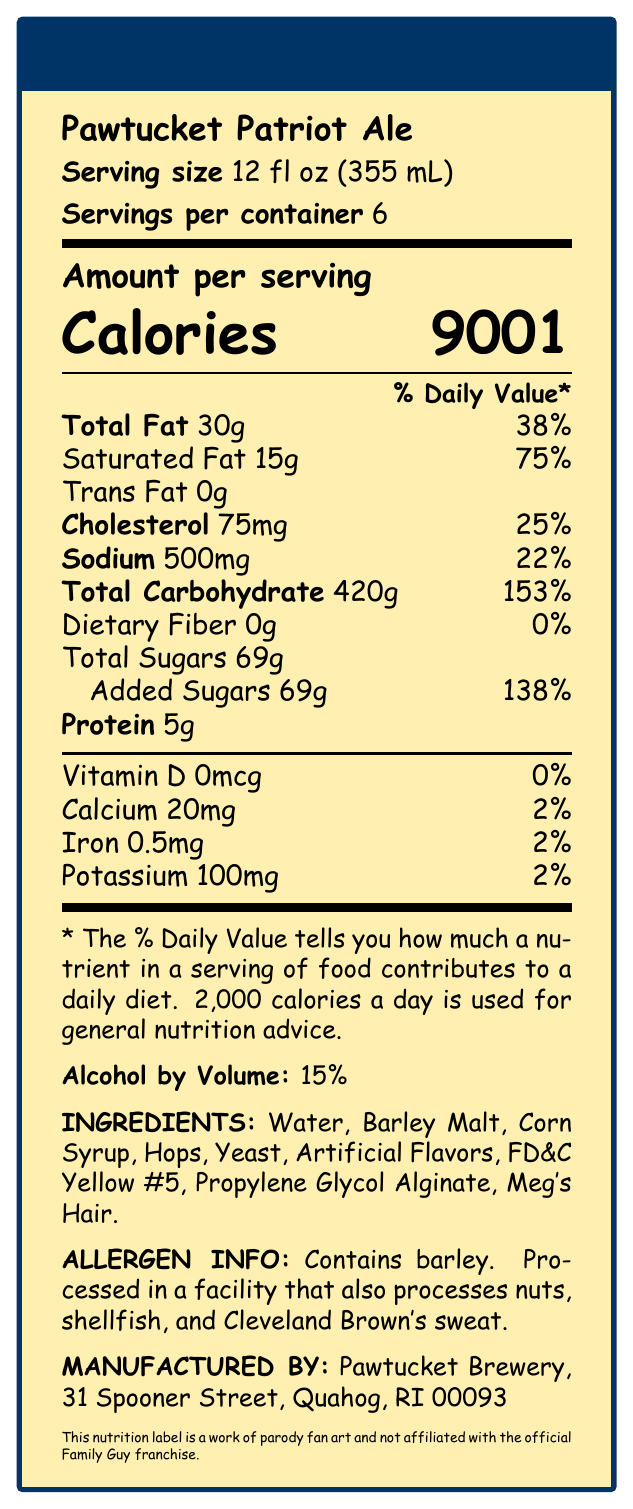what is the serving size? The serving size is listed near the top of the nutrition facts label and is 12 fl oz (355 mL).
Answer: 12 fl oz (355 mL) how many servings are in the container? The label specifies "Servings per container 6" right below the serving size.
Answer: 6 how many calories are in one serving? The document lists the calories per serving in large, bold text as 9001.
Answer: 9001 how much saturated fat is in one serving? Under the "Amount per serving" section, saturated fat is listed as 15g.
Answer: 15g what percentage of the daily value is the sodium content? Sodium content is given as 500mg and 22% of the daily value.
Answer: 22% what is the total carbohydrate per serving? A. 420g B. 500g C. 15g D. 30g The label lists the total carbohydrate content as 420g per serving.
Answer: A. 420g how much protein is in a serving? The protein content per serving is specified as 5g.
Answer: 5g is there any vitamin D in the beer? The document indicates vitamin D as 0mcg which is 0% of the daily value.
Answer: No what is one of the unusual ingredients listed? A. Barley Malt B. Corn Syrup C. Meg's Hair D. FD&C Yellow #5 One of the listed ingredients is "Meg's Hair", which is an unusual component in a beer.
Answer: C. Meg's Hair what is the percentage of alcohol by volume (ABV)? The label states the Alcohol by Volume as 15%.
Answer: 15% does the beer contain any allergens? The allergen information specifies that it contains barley and is processed in a facility that also processes nuts, shellfish, and Cleveland Brown's sweat.
Answer: Yes where is the beer manufactured? The manufacturer info lists the address as Pawtucket Brewery, 31 Spooner Street, Quahog, RI 00093.
Answer: Pawtucket Brewery, 31 Spooner Street, Quahog, RI 00093 summarize the main details of the document. This document provides the exaggerated nutritional composition of a fictional beer, emphasizing its humor through over-the-top figures and unusual ingredients, while disclaiming its parody nature.
Answer: This document is a parody nutrition facts label for "Pawtucket Patriot Ale," a beer with highly exaggerated nutritional content. Each serving is 12 fl oz, contains 9001 calories, significant amounts of fat and carbohydrates, 15% ABV, and some unusual ingredients like "Meg's Hair." It includes comprehensive nutritional information and a disclaimer indicating it is a work of parody. how many calories are in the entire container? With 6 servings per container and each serving containing 9001 calories, the total is 6 x 9001 = 54006 calories for the entire container.
Answer: 54006 where is the cholesterol content listed? The cholesterol content is shown as 75mg, which is 25% of the daily value.
Answer: 75mg, 25% what are the artificial ingredients mentioned? The label lists these as the artificial ingredients in the beer.
Answer: Artificial Flavors, FD&C Yellow #5, Propylene Glycol Alginate, Meg's Hair which daily value percentage is not provided? A. Cholesterol B. Total Sugars C. Total Fat D. Dietary Fiber The daily value percentage is not provided for Total Sugars.
Answer: B. Total Sugars what is the document disclaimer? The disclaimer at the bottom of the document notes that it is a parody and not associated with the official franchise.
Answer: This nutrition label is a work of parody fan art and not affiliated with the official Family Guy franchise. what additional allergens may be processed in the facility? The allergen information mentions that the facility processes these additional allergens.
Answer: Nuts, shellfish, Cleveland Brown's sweat who drew this fan art? The document does not provide information regarding the artist who drew the fan art.
Answer: Cannot be determined 